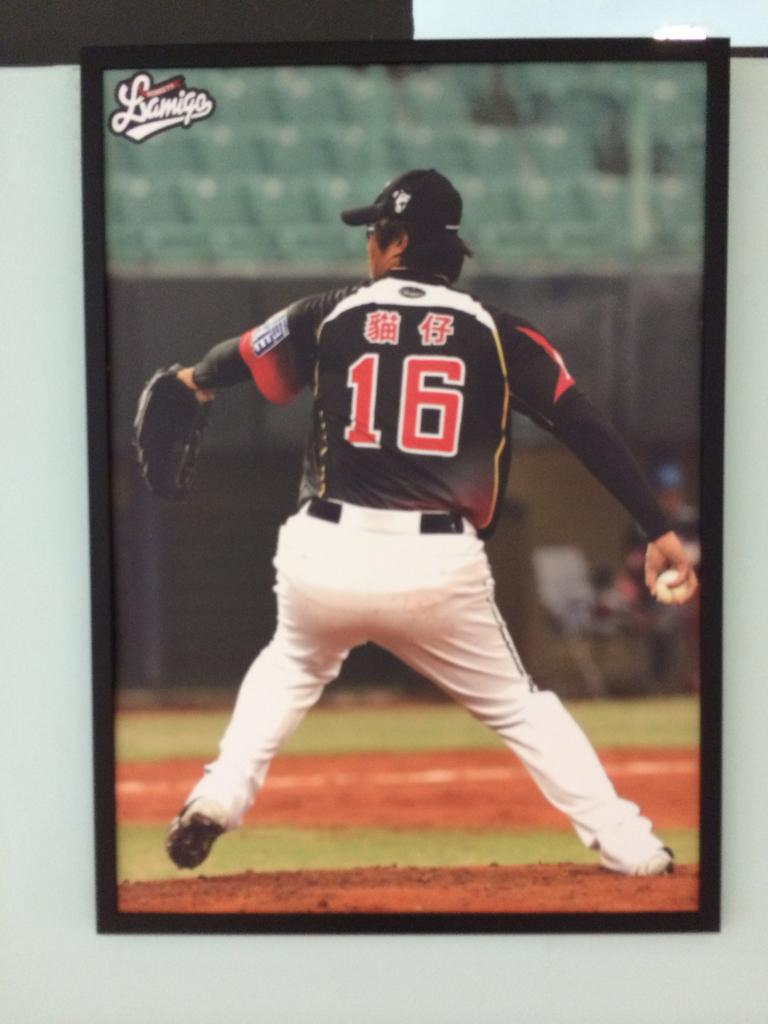<image>
Present a compact description of the photo's key features. Player number 16 has the ball in his right hand. 